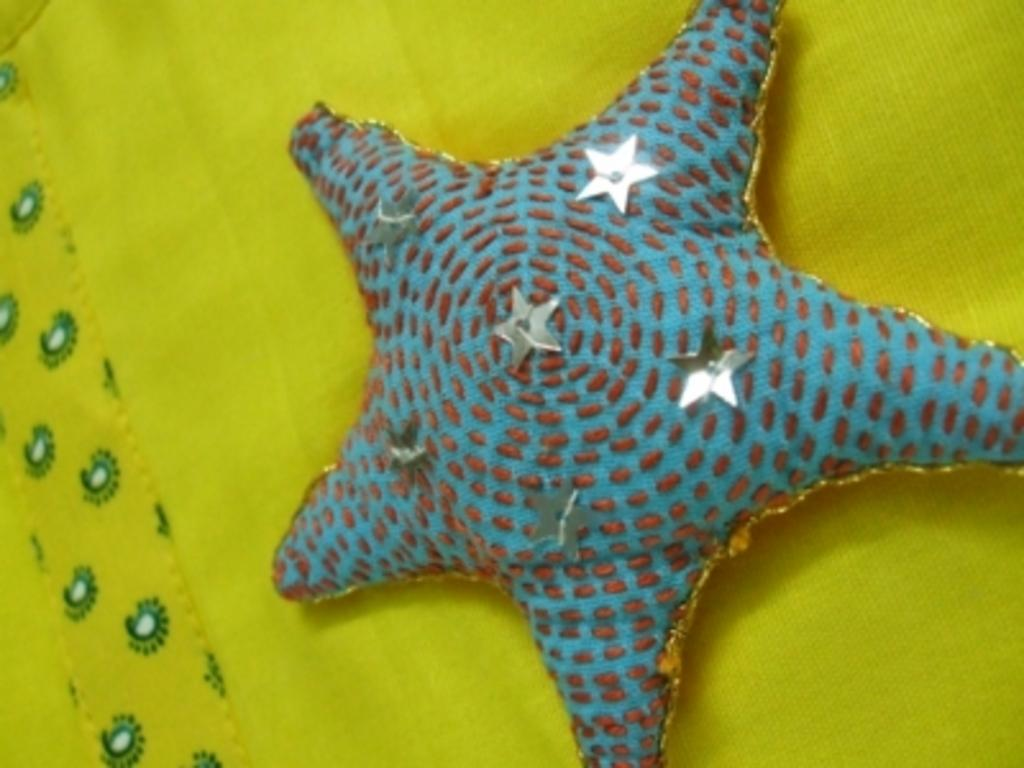What is the primary color of the star in the image? The primary color of the star in the image is blue. What other color is present in the star? The star also has white color in it. What is the star placed on in the image? The star is on a yellow and green color cloth. What type of birds can be seen playing with soap in the image? There are no birds or soap present in the image; it features a blue and white star on a yellow and green cloth. 